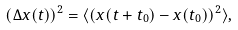Convert formula to latex. <formula><loc_0><loc_0><loc_500><loc_500>( \Delta x ( t ) ) ^ { 2 } = \langle ( x ( t + t _ { 0 } ) - x ( t _ { 0 } ) ) ^ { 2 } \rangle ,</formula> 